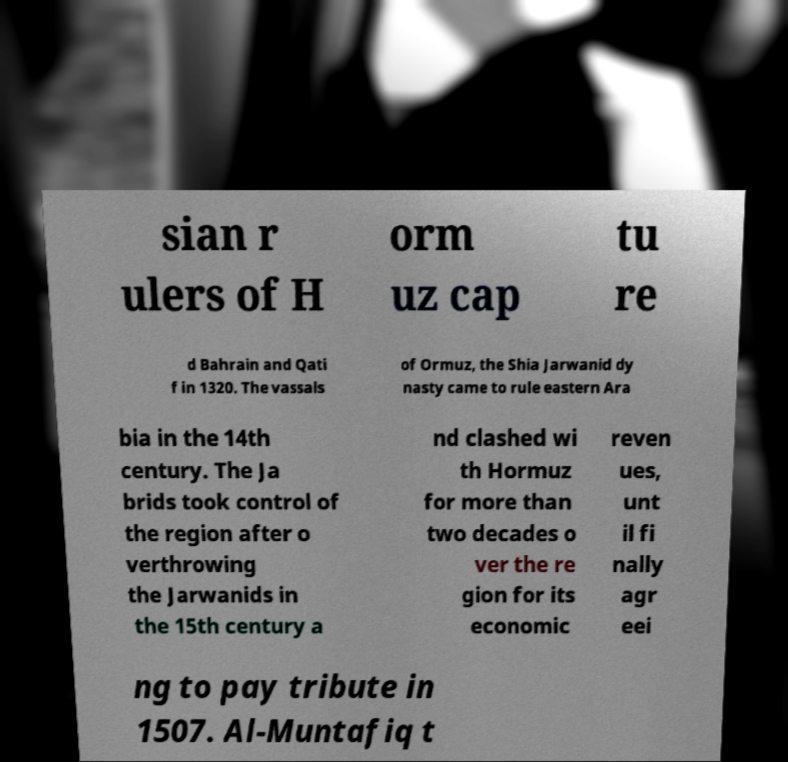Please identify and transcribe the text found in this image. sian r ulers of H orm uz cap tu re d Bahrain and Qati f in 1320. The vassals of Ormuz, the Shia Jarwanid dy nasty came to rule eastern Ara bia in the 14th century. The Ja brids took control of the region after o verthrowing the Jarwanids in the 15th century a nd clashed wi th Hormuz for more than two decades o ver the re gion for its economic reven ues, unt il fi nally agr eei ng to pay tribute in 1507. Al-Muntafiq t 